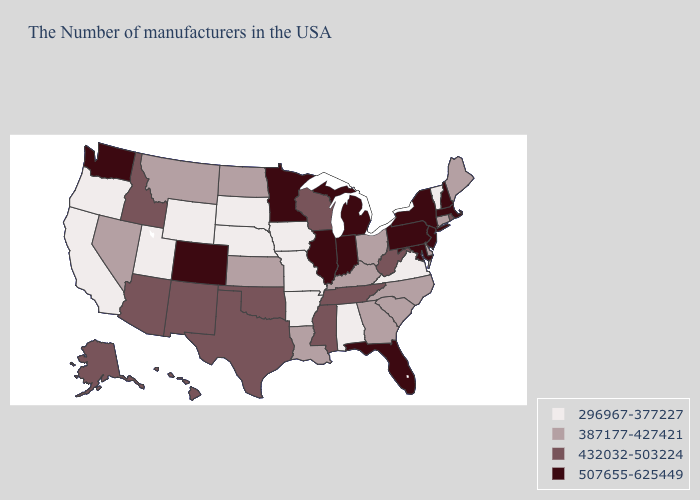What is the value of North Carolina?
Keep it brief. 387177-427421. What is the highest value in the South ?
Keep it brief. 507655-625449. What is the lowest value in the USA?
Be succinct. 296967-377227. Name the states that have a value in the range 507655-625449?
Keep it brief. Massachusetts, New Hampshire, New York, New Jersey, Maryland, Pennsylvania, Florida, Michigan, Indiana, Illinois, Minnesota, Colorado, Washington. Among the states that border Nebraska , does South Dakota have the lowest value?
Be succinct. Yes. What is the lowest value in the USA?
Write a very short answer. 296967-377227. Does the map have missing data?
Answer briefly. No. Does Rhode Island have the highest value in the Northeast?
Give a very brief answer. No. Name the states that have a value in the range 507655-625449?
Keep it brief. Massachusetts, New Hampshire, New York, New Jersey, Maryland, Pennsylvania, Florida, Michigan, Indiana, Illinois, Minnesota, Colorado, Washington. Among the states that border Arizona , does California have the highest value?
Concise answer only. No. What is the value of Vermont?
Answer briefly. 296967-377227. What is the value of Virginia?
Concise answer only. 296967-377227. Does the map have missing data?
Concise answer only. No. Which states have the highest value in the USA?
Concise answer only. Massachusetts, New Hampshire, New York, New Jersey, Maryland, Pennsylvania, Florida, Michigan, Indiana, Illinois, Minnesota, Colorado, Washington. Name the states that have a value in the range 432032-503224?
Write a very short answer. Rhode Island, West Virginia, Tennessee, Wisconsin, Mississippi, Oklahoma, Texas, New Mexico, Arizona, Idaho, Alaska, Hawaii. 